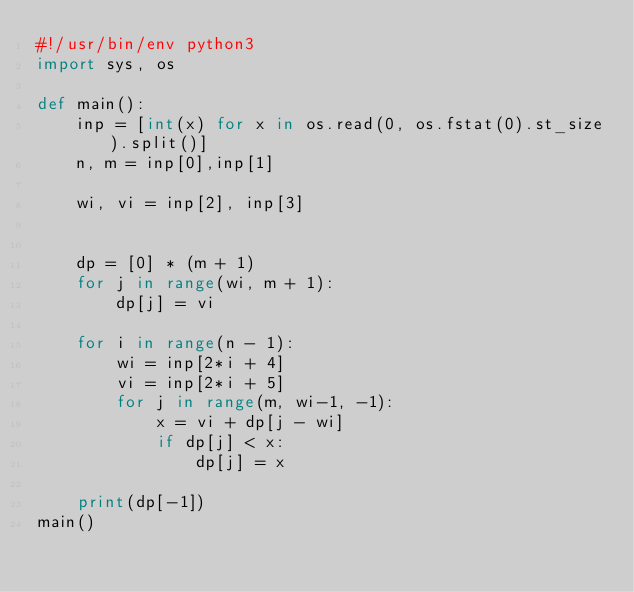Convert code to text. <code><loc_0><loc_0><loc_500><loc_500><_Python_>#!/usr/bin/env python3
import sys, os
 
def main():
    inp = [int(x) for x in os.read(0, os.fstat(0).st_size).split()]
    n, m = inp[0],inp[1]
 
    wi, vi = inp[2], inp[3]
 
 
    dp = [0] * (m + 1)
    for j in range(wi, m + 1):
        dp[j] = vi
 
    for i in range(n - 1):
        wi = inp[2*i + 4]
        vi = inp[2*i + 5]
        for j in range(m, wi-1, -1):
            x = vi + dp[j - wi]
            if dp[j] < x:
                dp[j] = x
 
    print(dp[-1])
main()
</code> 